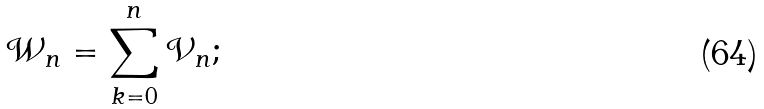<formula> <loc_0><loc_0><loc_500><loc_500>\mathcal { W } _ { n } = \sum _ { k = 0 } ^ { n } \mathcal { V } _ { n } ;</formula> 